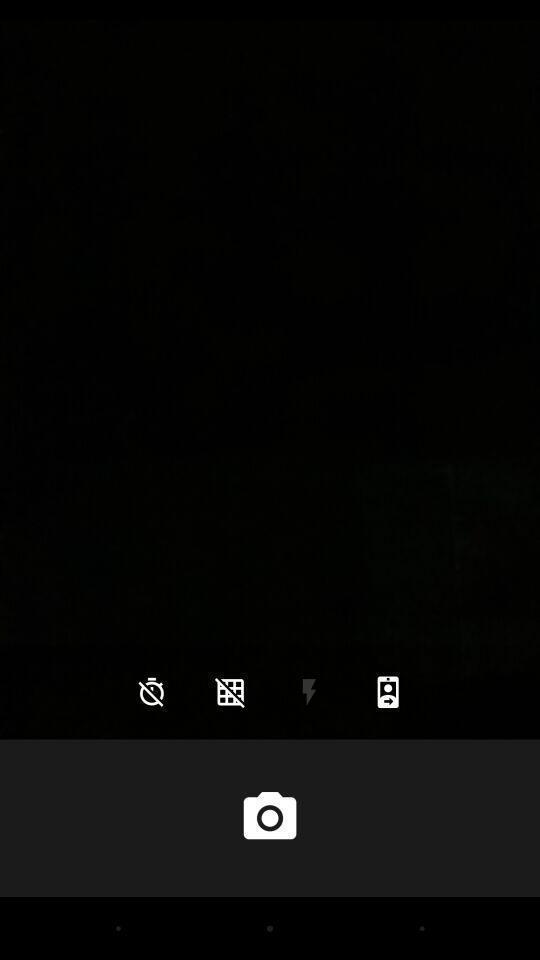Provide a description of this screenshot. Screen displaying the camera icon and other options. 